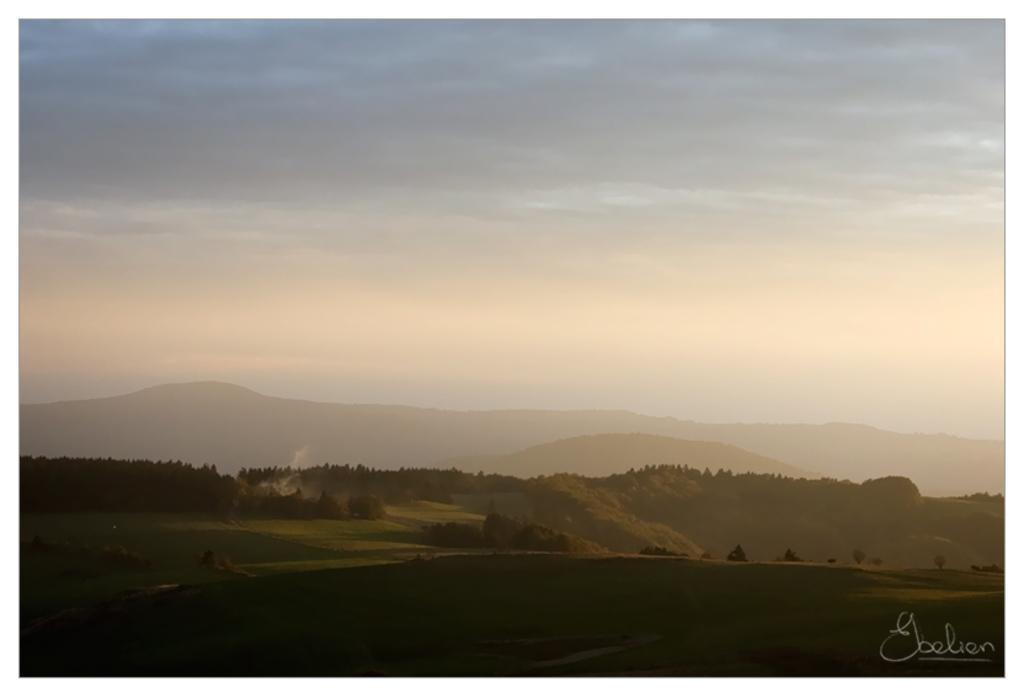What type of natural landform can be seen in the image? There are mountains in the image. What type of vegetation is present in the image? There are trees in the image. What type of ground cover is visible at the bottom of the image? There is grass at the bottom of the image. What is visible at the top of the image? The sky is visible at the top of the image. Where is the quill located in the image? There is no quill present in the image. What type of furniture is in the lunchroom in the image? There is no lunchroom present in the image. 